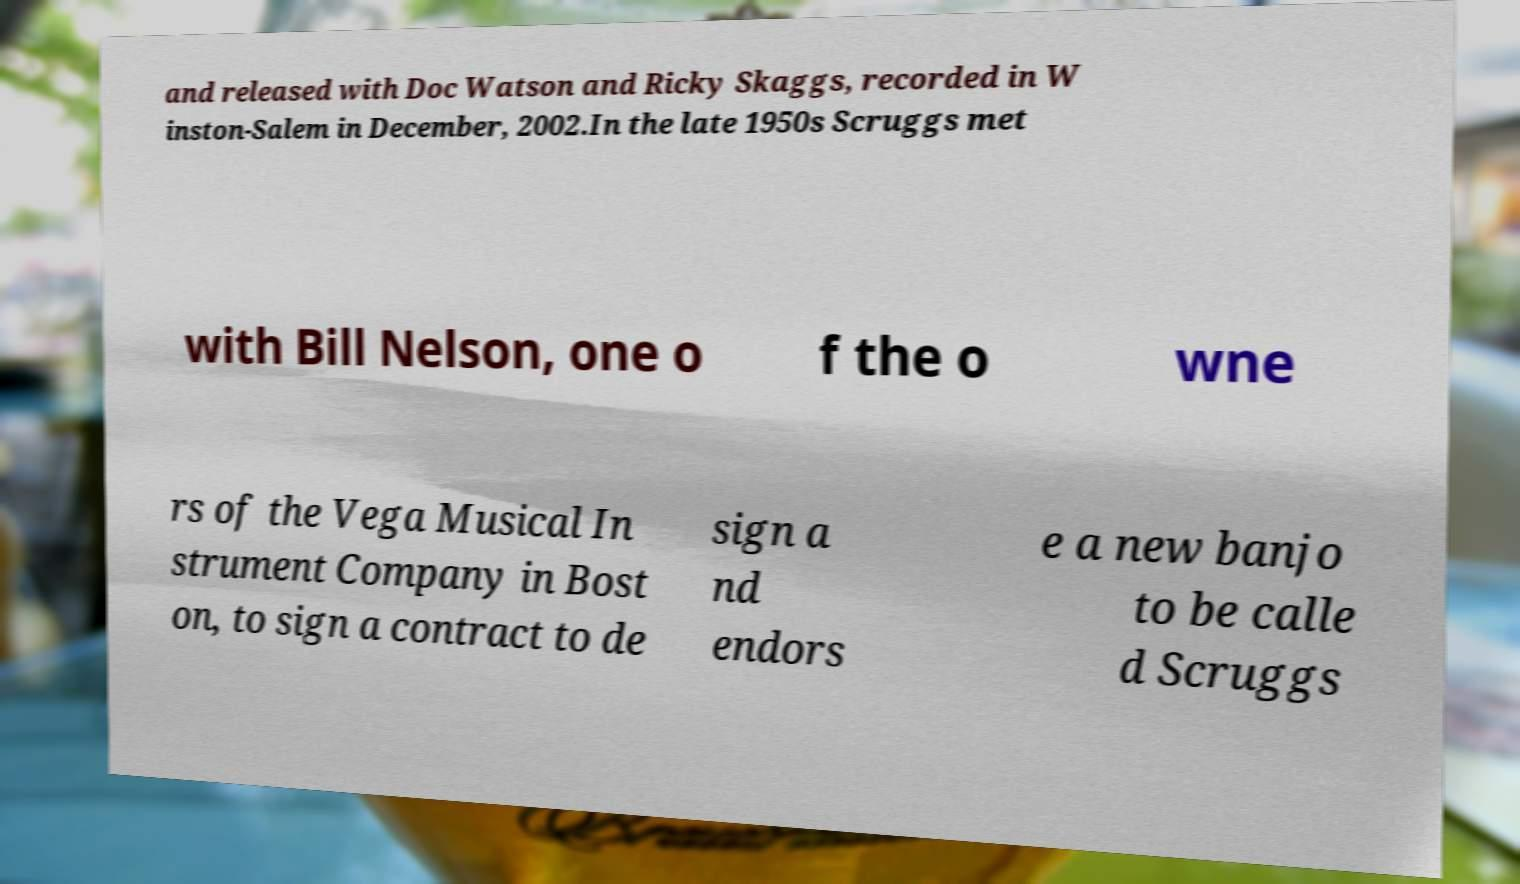For documentation purposes, I need the text within this image transcribed. Could you provide that? and released with Doc Watson and Ricky Skaggs, recorded in W inston-Salem in December, 2002.In the late 1950s Scruggs met with Bill Nelson, one o f the o wne rs of the Vega Musical In strument Company in Bost on, to sign a contract to de sign a nd endors e a new banjo to be calle d Scruggs 